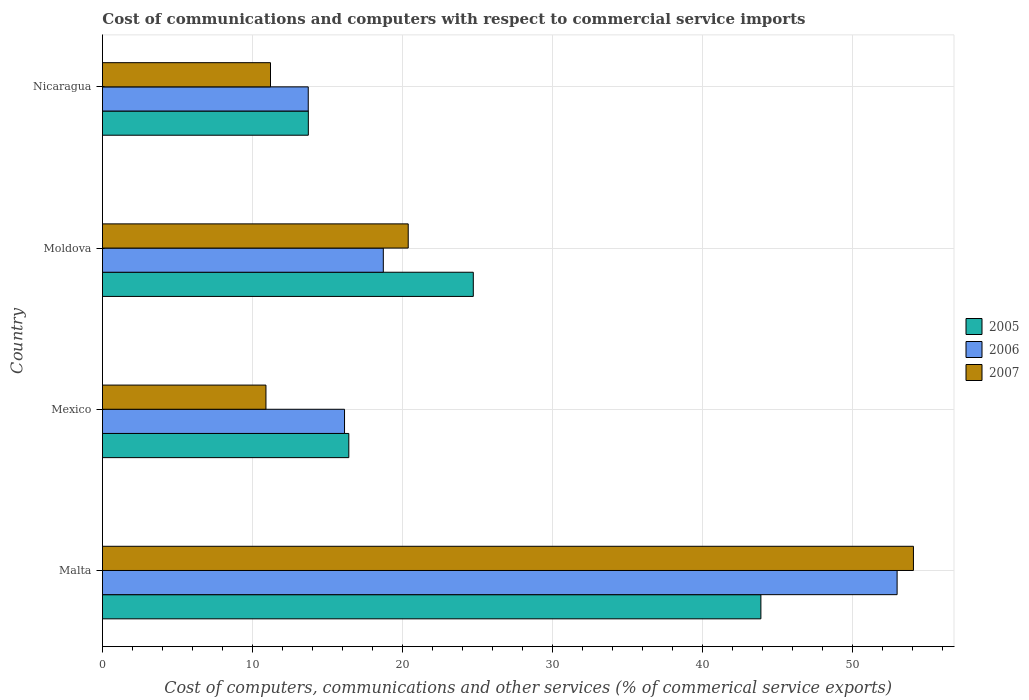Are the number of bars per tick equal to the number of legend labels?
Ensure brevity in your answer.  Yes. How many bars are there on the 2nd tick from the top?
Provide a succinct answer. 3. How many bars are there on the 2nd tick from the bottom?
Provide a short and direct response. 3. What is the label of the 2nd group of bars from the top?
Provide a short and direct response. Moldova. What is the cost of communications and computers in 2005 in Nicaragua?
Offer a terse response. 13.72. Across all countries, what is the maximum cost of communications and computers in 2005?
Provide a succinct answer. 43.87. Across all countries, what is the minimum cost of communications and computers in 2005?
Your answer should be compact. 13.72. In which country was the cost of communications and computers in 2007 maximum?
Ensure brevity in your answer.  Malta. In which country was the cost of communications and computers in 2006 minimum?
Your answer should be very brief. Nicaragua. What is the total cost of communications and computers in 2005 in the graph?
Your answer should be very brief. 98.71. What is the difference between the cost of communications and computers in 2006 in Moldova and that in Nicaragua?
Your response must be concise. 5. What is the difference between the cost of communications and computers in 2007 in Moldova and the cost of communications and computers in 2005 in Malta?
Give a very brief answer. -23.5. What is the average cost of communications and computers in 2007 per country?
Keep it short and to the point. 24.12. What is the difference between the cost of communications and computers in 2006 and cost of communications and computers in 2005 in Nicaragua?
Give a very brief answer. -0.01. What is the ratio of the cost of communications and computers in 2006 in Malta to that in Nicaragua?
Give a very brief answer. 3.86. Is the difference between the cost of communications and computers in 2006 in Malta and Nicaragua greater than the difference between the cost of communications and computers in 2005 in Malta and Nicaragua?
Give a very brief answer. Yes. What is the difference between the highest and the second highest cost of communications and computers in 2006?
Ensure brevity in your answer.  34.23. What is the difference between the highest and the lowest cost of communications and computers in 2005?
Give a very brief answer. 30.15. In how many countries, is the cost of communications and computers in 2005 greater than the average cost of communications and computers in 2005 taken over all countries?
Ensure brevity in your answer.  2. Is the sum of the cost of communications and computers in 2006 in Mexico and Nicaragua greater than the maximum cost of communications and computers in 2007 across all countries?
Offer a very short reply. No. What does the 3rd bar from the top in Nicaragua represents?
Make the answer very short. 2005. What does the 3rd bar from the bottom in Nicaragua represents?
Keep it short and to the point. 2007. Are all the bars in the graph horizontal?
Ensure brevity in your answer.  Yes. How many countries are there in the graph?
Give a very brief answer. 4. Are the values on the major ticks of X-axis written in scientific E-notation?
Provide a short and direct response. No. Does the graph contain any zero values?
Provide a short and direct response. No. Does the graph contain grids?
Your response must be concise. Yes. How are the legend labels stacked?
Give a very brief answer. Vertical. What is the title of the graph?
Keep it short and to the point. Cost of communications and computers with respect to commercial service imports. Does "1982" appear as one of the legend labels in the graph?
Your answer should be compact. No. What is the label or title of the X-axis?
Offer a terse response. Cost of computers, communications and other services (% of commerical service exports). What is the Cost of computers, communications and other services (% of commerical service exports) in 2005 in Malta?
Keep it short and to the point. 43.87. What is the Cost of computers, communications and other services (% of commerical service exports) in 2006 in Malta?
Provide a succinct answer. 52.94. What is the Cost of computers, communications and other services (% of commerical service exports) of 2007 in Malta?
Keep it short and to the point. 54.03. What is the Cost of computers, communications and other services (% of commerical service exports) in 2005 in Mexico?
Make the answer very short. 16.41. What is the Cost of computers, communications and other services (% of commerical service exports) of 2006 in Mexico?
Provide a succinct answer. 16.13. What is the Cost of computers, communications and other services (% of commerical service exports) in 2007 in Mexico?
Offer a very short reply. 10.89. What is the Cost of computers, communications and other services (% of commerical service exports) in 2005 in Moldova?
Your answer should be very brief. 24.71. What is the Cost of computers, communications and other services (% of commerical service exports) in 2006 in Moldova?
Keep it short and to the point. 18.71. What is the Cost of computers, communications and other services (% of commerical service exports) of 2007 in Moldova?
Ensure brevity in your answer.  20.37. What is the Cost of computers, communications and other services (% of commerical service exports) of 2005 in Nicaragua?
Your response must be concise. 13.72. What is the Cost of computers, communications and other services (% of commerical service exports) in 2006 in Nicaragua?
Ensure brevity in your answer.  13.71. What is the Cost of computers, communications and other services (% of commerical service exports) of 2007 in Nicaragua?
Your response must be concise. 11.2. Across all countries, what is the maximum Cost of computers, communications and other services (% of commerical service exports) in 2005?
Provide a short and direct response. 43.87. Across all countries, what is the maximum Cost of computers, communications and other services (% of commerical service exports) in 2006?
Provide a succinct answer. 52.94. Across all countries, what is the maximum Cost of computers, communications and other services (% of commerical service exports) of 2007?
Offer a terse response. 54.03. Across all countries, what is the minimum Cost of computers, communications and other services (% of commerical service exports) of 2005?
Your answer should be very brief. 13.72. Across all countries, what is the minimum Cost of computers, communications and other services (% of commerical service exports) of 2006?
Keep it short and to the point. 13.71. Across all countries, what is the minimum Cost of computers, communications and other services (% of commerical service exports) of 2007?
Provide a short and direct response. 10.89. What is the total Cost of computers, communications and other services (% of commerical service exports) of 2005 in the graph?
Provide a short and direct response. 98.71. What is the total Cost of computers, communications and other services (% of commerical service exports) in 2006 in the graph?
Offer a very short reply. 101.5. What is the total Cost of computers, communications and other services (% of commerical service exports) in 2007 in the graph?
Make the answer very short. 96.49. What is the difference between the Cost of computers, communications and other services (% of commerical service exports) in 2005 in Malta and that in Mexico?
Make the answer very short. 27.46. What is the difference between the Cost of computers, communications and other services (% of commerical service exports) in 2006 in Malta and that in Mexico?
Provide a short and direct response. 36.82. What is the difference between the Cost of computers, communications and other services (% of commerical service exports) of 2007 in Malta and that in Mexico?
Keep it short and to the point. 43.14. What is the difference between the Cost of computers, communications and other services (% of commerical service exports) in 2005 in Malta and that in Moldova?
Keep it short and to the point. 19.16. What is the difference between the Cost of computers, communications and other services (% of commerical service exports) in 2006 in Malta and that in Moldova?
Offer a very short reply. 34.23. What is the difference between the Cost of computers, communications and other services (% of commerical service exports) in 2007 in Malta and that in Moldova?
Give a very brief answer. 33.66. What is the difference between the Cost of computers, communications and other services (% of commerical service exports) of 2005 in Malta and that in Nicaragua?
Offer a very short reply. 30.15. What is the difference between the Cost of computers, communications and other services (% of commerical service exports) in 2006 in Malta and that in Nicaragua?
Ensure brevity in your answer.  39.23. What is the difference between the Cost of computers, communications and other services (% of commerical service exports) of 2007 in Malta and that in Nicaragua?
Provide a succinct answer. 42.84. What is the difference between the Cost of computers, communications and other services (% of commerical service exports) of 2005 in Mexico and that in Moldova?
Offer a very short reply. -8.29. What is the difference between the Cost of computers, communications and other services (% of commerical service exports) of 2006 in Mexico and that in Moldova?
Offer a very short reply. -2.58. What is the difference between the Cost of computers, communications and other services (% of commerical service exports) in 2007 in Mexico and that in Moldova?
Ensure brevity in your answer.  -9.48. What is the difference between the Cost of computers, communications and other services (% of commerical service exports) of 2005 in Mexico and that in Nicaragua?
Offer a terse response. 2.7. What is the difference between the Cost of computers, communications and other services (% of commerical service exports) of 2006 in Mexico and that in Nicaragua?
Offer a very short reply. 2.42. What is the difference between the Cost of computers, communications and other services (% of commerical service exports) of 2007 in Mexico and that in Nicaragua?
Offer a very short reply. -0.3. What is the difference between the Cost of computers, communications and other services (% of commerical service exports) in 2005 in Moldova and that in Nicaragua?
Offer a terse response. 10.99. What is the difference between the Cost of computers, communications and other services (% of commerical service exports) of 2006 in Moldova and that in Nicaragua?
Provide a succinct answer. 5. What is the difference between the Cost of computers, communications and other services (% of commerical service exports) in 2007 in Moldova and that in Nicaragua?
Your answer should be very brief. 9.18. What is the difference between the Cost of computers, communications and other services (% of commerical service exports) of 2005 in Malta and the Cost of computers, communications and other services (% of commerical service exports) of 2006 in Mexico?
Your response must be concise. 27.74. What is the difference between the Cost of computers, communications and other services (% of commerical service exports) in 2005 in Malta and the Cost of computers, communications and other services (% of commerical service exports) in 2007 in Mexico?
Provide a short and direct response. 32.98. What is the difference between the Cost of computers, communications and other services (% of commerical service exports) of 2006 in Malta and the Cost of computers, communications and other services (% of commerical service exports) of 2007 in Mexico?
Offer a terse response. 42.05. What is the difference between the Cost of computers, communications and other services (% of commerical service exports) in 2005 in Malta and the Cost of computers, communications and other services (% of commerical service exports) in 2006 in Moldova?
Make the answer very short. 25.16. What is the difference between the Cost of computers, communications and other services (% of commerical service exports) in 2005 in Malta and the Cost of computers, communications and other services (% of commerical service exports) in 2007 in Moldova?
Ensure brevity in your answer.  23.5. What is the difference between the Cost of computers, communications and other services (% of commerical service exports) in 2006 in Malta and the Cost of computers, communications and other services (% of commerical service exports) in 2007 in Moldova?
Give a very brief answer. 32.57. What is the difference between the Cost of computers, communications and other services (% of commerical service exports) in 2005 in Malta and the Cost of computers, communications and other services (% of commerical service exports) in 2006 in Nicaragua?
Your answer should be compact. 30.16. What is the difference between the Cost of computers, communications and other services (% of commerical service exports) of 2005 in Malta and the Cost of computers, communications and other services (% of commerical service exports) of 2007 in Nicaragua?
Your answer should be very brief. 32.67. What is the difference between the Cost of computers, communications and other services (% of commerical service exports) of 2006 in Malta and the Cost of computers, communications and other services (% of commerical service exports) of 2007 in Nicaragua?
Offer a terse response. 41.75. What is the difference between the Cost of computers, communications and other services (% of commerical service exports) of 2005 in Mexico and the Cost of computers, communications and other services (% of commerical service exports) of 2006 in Moldova?
Give a very brief answer. -2.3. What is the difference between the Cost of computers, communications and other services (% of commerical service exports) of 2005 in Mexico and the Cost of computers, communications and other services (% of commerical service exports) of 2007 in Moldova?
Keep it short and to the point. -3.96. What is the difference between the Cost of computers, communications and other services (% of commerical service exports) in 2006 in Mexico and the Cost of computers, communications and other services (% of commerical service exports) in 2007 in Moldova?
Your answer should be very brief. -4.24. What is the difference between the Cost of computers, communications and other services (% of commerical service exports) in 2005 in Mexico and the Cost of computers, communications and other services (% of commerical service exports) in 2006 in Nicaragua?
Your answer should be compact. 2.7. What is the difference between the Cost of computers, communications and other services (% of commerical service exports) in 2005 in Mexico and the Cost of computers, communications and other services (% of commerical service exports) in 2007 in Nicaragua?
Provide a short and direct response. 5.22. What is the difference between the Cost of computers, communications and other services (% of commerical service exports) in 2006 in Mexico and the Cost of computers, communications and other services (% of commerical service exports) in 2007 in Nicaragua?
Your answer should be very brief. 4.93. What is the difference between the Cost of computers, communications and other services (% of commerical service exports) in 2005 in Moldova and the Cost of computers, communications and other services (% of commerical service exports) in 2006 in Nicaragua?
Give a very brief answer. 11. What is the difference between the Cost of computers, communications and other services (% of commerical service exports) in 2005 in Moldova and the Cost of computers, communications and other services (% of commerical service exports) in 2007 in Nicaragua?
Offer a very short reply. 13.51. What is the difference between the Cost of computers, communications and other services (% of commerical service exports) in 2006 in Moldova and the Cost of computers, communications and other services (% of commerical service exports) in 2007 in Nicaragua?
Make the answer very short. 7.52. What is the average Cost of computers, communications and other services (% of commerical service exports) in 2005 per country?
Your answer should be very brief. 24.68. What is the average Cost of computers, communications and other services (% of commerical service exports) of 2006 per country?
Make the answer very short. 25.37. What is the average Cost of computers, communications and other services (% of commerical service exports) of 2007 per country?
Your response must be concise. 24.12. What is the difference between the Cost of computers, communications and other services (% of commerical service exports) in 2005 and Cost of computers, communications and other services (% of commerical service exports) in 2006 in Malta?
Provide a succinct answer. -9.08. What is the difference between the Cost of computers, communications and other services (% of commerical service exports) of 2005 and Cost of computers, communications and other services (% of commerical service exports) of 2007 in Malta?
Give a very brief answer. -10.16. What is the difference between the Cost of computers, communications and other services (% of commerical service exports) of 2006 and Cost of computers, communications and other services (% of commerical service exports) of 2007 in Malta?
Give a very brief answer. -1.09. What is the difference between the Cost of computers, communications and other services (% of commerical service exports) of 2005 and Cost of computers, communications and other services (% of commerical service exports) of 2006 in Mexico?
Your answer should be very brief. 0.29. What is the difference between the Cost of computers, communications and other services (% of commerical service exports) in 2005 and Cost of computers, communications and other services (% of commerical service exports) in 2007 in Mexico?
Your answer should be compact. 5.52. What is the difference between the Cost of computers, communications and other services (% of commerical service exports) of 2006 and Cost of computers, communications and other services (% of commerical service exports) of 2007 in Mexico?
Your response must be concise. 5.23. What is the difference between the Cost of computers, communications and other services (% of commerical service exports) in 2005 and Cost of computers, communications and other services (% of commerical service exports) in 2006 in Moldova?
Provide a short and direct response. 6. What is the difference between the Cost of computers, communications and other services (% of commerical service exports) in 2005 and Cost of computers, communications and other services (% of commerical service exports) in 2007 in Moldova?
Provide a short and direct response. 4.34. What is the difference between the Cost of computers, communications and other services (% of commerical service exports) of 2006 and Cost of computers, communications and other services (% of commerical service exports) of 2007 in Moldova?
Your response must be concise. -1.66. What is the difference between the Cost of computers, communications and other services (% of commerical service exports) in 2005 and Cost of computers, communications and other services (% of commerical service exports) in 2006 in Nicaragua?
Give a very brief answer. 0.01. What is the difference between the Cost of computers, communications and other services (% of commerical service exports) of 2005 and Cost of computers, communications and other services (% of commerical service exports) of 2007 in Nicaragua?
Your answer should be very brief. 2.52. What is the difference between the Cost of computers, communications and other services (% of commerical service exports) of 2006 and Cost of computers, communications and other services (% of commerical service exports) of 2007 in Nicaragua?
Your answer should be very brief. 2.52. What is the ratio of the Cost of computers, communications and other services (% of commerical service exports) of 2005 in Malta to that in Mexico?
Offer a very short reply. 2.67. What is the ratio of the Cost of computers, communications and other services (% of commerical service exports) in 2006 in Malta to that in Mexico?
Provide a succinct answer. 3.28. What is the ratio of the Cost of computers, communications and other services (% of commerical service exports) of 2007 in Malta to that in Mexico?
Provide a short and direct response. 4.96. What is the ratio of the Cost of computers, communications and other services (% of commerical service exports) of 2005 in Malta to that in Moldova?
Provide a short and direct response. 1.78. What is the ratio of the Cost of computers, communications and other services (% of commerical service exports) of 2006 in Malta to that in Moldova?
Provide a short and direct response. 2.83. What is the ratio of the Cost of computers, communications and other services (% of commerical service exports) of 2007 in Malta to that in Moldova?
Give a very brief answer. 2.65. What is the ratio of the Cost of computers, communications and other services (% of commerical service exports) of 2005 in Malta to that in Nicaragua?
Provide a short and direct response. 3.2. What is the ratio of the Cost of computers, communications and other services (% of commerical service exports) in 2006 in Malta to that in Nicaragua?
Offer a terse response. 3.86. What is the ratio of the Cost of computers, communications and other services (% of commerical service exports) in 2007 in Malta to that in Nicaragua?
Give a very brief answer. 4.83. What is the ratio of the Cost of computers, communications and other services (% of commerical service exports) in 2005 in Mexico to that in Moldova?
Offer a terse response. 0.66. What is the ratio of the Cost of computers, communications and other services (% of commerical service exports) in 2006 in Mexico to that in Moldova?
Your answer should be compact. 0.86. What is the ratio of the Cost of computers, communications and other services (% of commerical service exports) in 2007 in Mexico to that in Moldova?
Ensure brevity in your answer.  0.53. What is the ratio of the Cost of computers, communications and other services (% of commerical service exports) of 2005 in Mexico to that in Nicaragua?
Make the answer very short. 1.2. What is the ratio of the Cost of computers, communications and other services (% of commerical service exports) in 2006 in Mexico to that in Nicaragua?
Provide a short and direct response. 1.18. What is the ratio of the Cost of computers, communications and other services (% of commerical service exports) of 2007 in Mexico to that in Nicaragua?
Your answer should be very brief. 0.97. What is the ratio of the Cost of computers, communications and other services (% of commerical service exports) of 2005 in Moldova to that in Nicaragua?
Ensure brevity in your answer.  1.8. What is the ratio of the Cost of computers, communications and other services (% of commerical service exports) in 2006 in Moldova to that in Nicaragua?
Give a very brief answer. 1.36. What is the ratio of the Cost of computers, communications and other services (% of commerical service exports) in 2007 in Moldova to that in Nicaragua?
Offer a terse response. 1.82. What is the difference between the highest and the second highest Cost of computers, communications and other services (% of commerical service exports) in 2005?
Provide a succinct answer. 19.16. What is the difference between the highest and the second highest Cost of computers, communications and other services (% of commerical service exports) in 2006?
Make the answer very short. 34.23. What is the difference between the highest and the second highest Cost of computers, communications and other services (% of commerical service exports) of 2007?
Give a very brief answer. 33.66. What is the difference between the highest and the lowest Cost of computers, communications and other services (% of commerical service exports) of 2005?
Give a very brief answer. 30.15. What is the difference between the highest and the lowest Cost of computers, communications and other services (% of commerical service exports) in 2006?
Keep it short and to the point. 39.23. What is the difference between the highest and the lowest Cost of computers, communications and other services (% of commerical service exports) in 2007?
Make the answer very short. 43.14. 